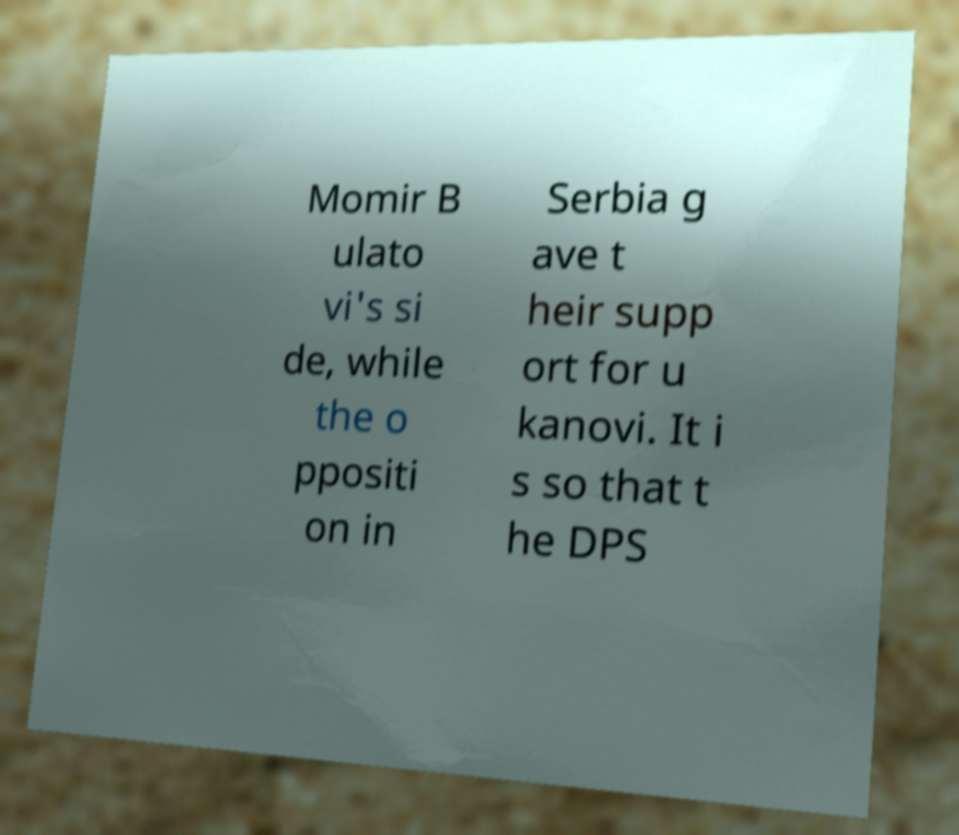Could you assist in decoding the text presented in this image and type it out clearly? Momir B ulato vi's si de, while the o ppositi on in Serbia g ave t heir supp ort for u kanovi. It i s so that t he DPS 